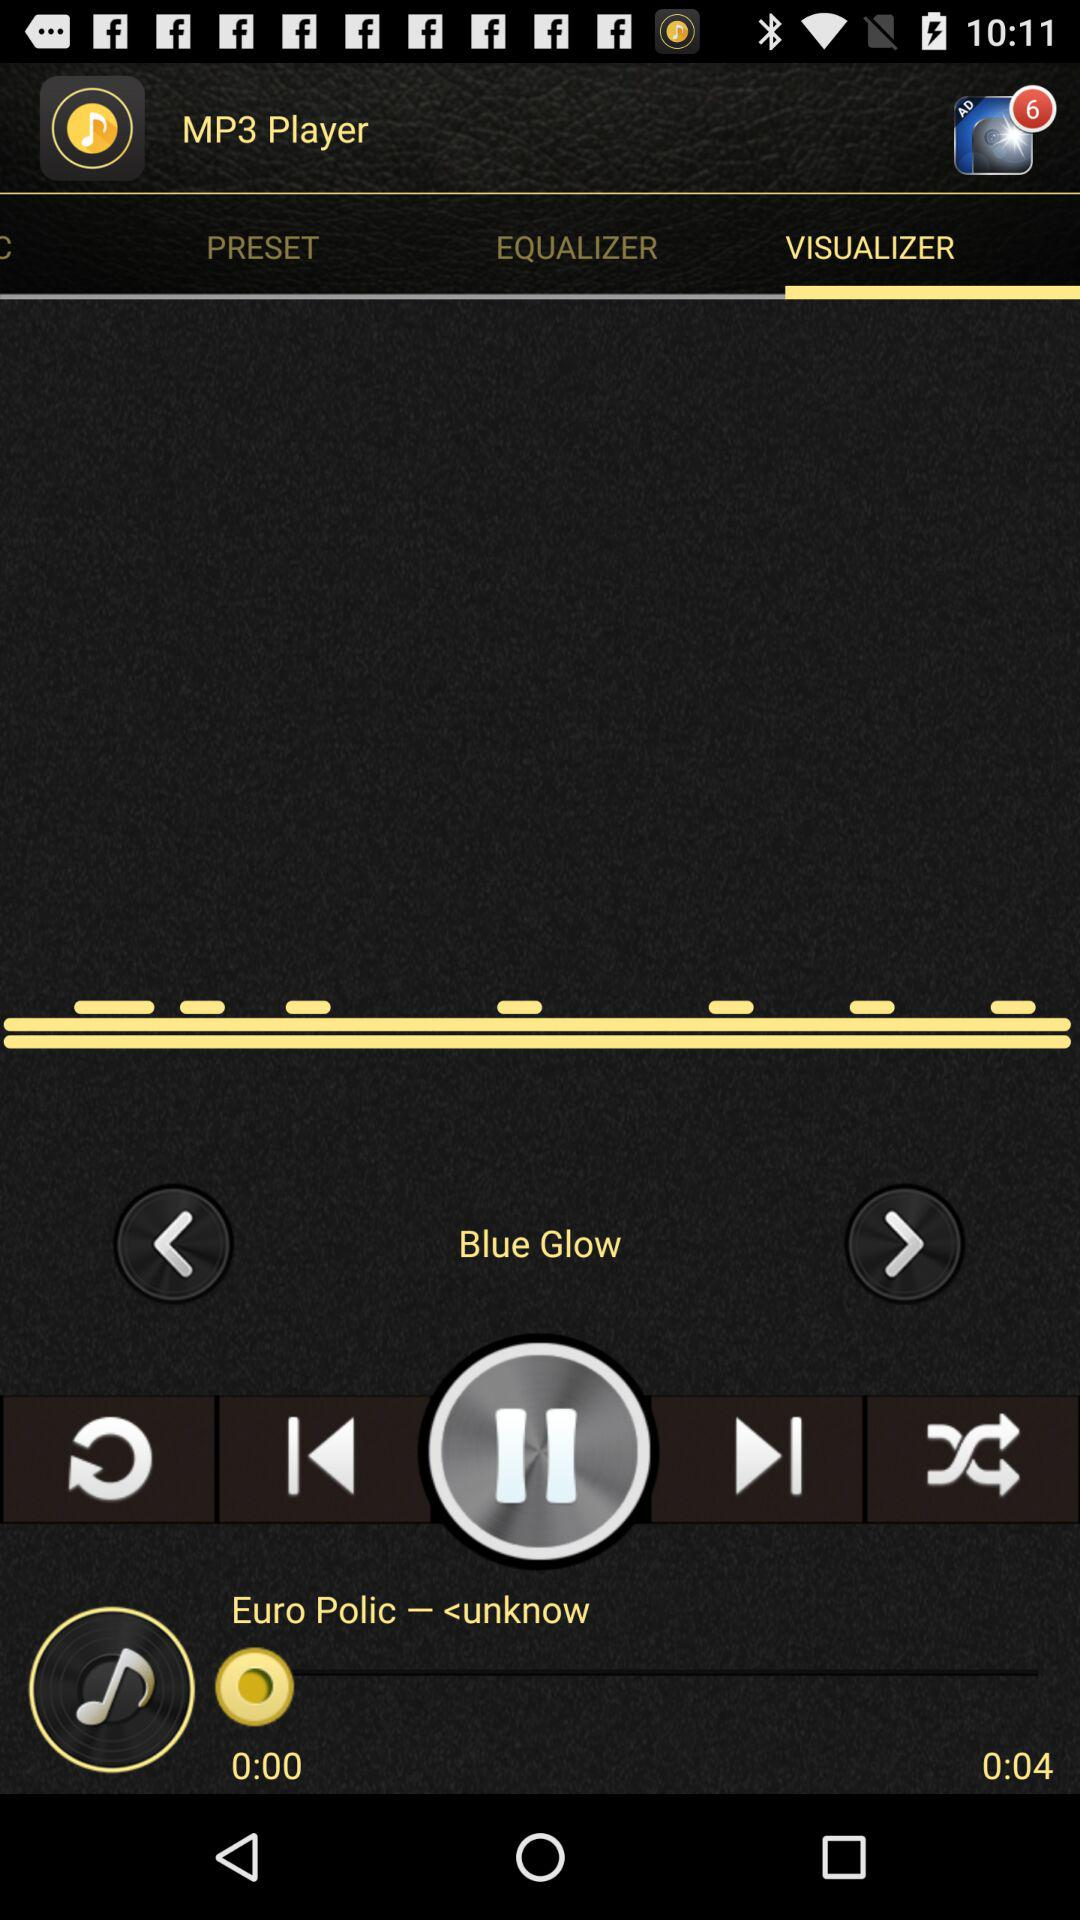How many seconds longer is the duration of the song than the current playback time?
Answer the question using a single word or phrase. 4 